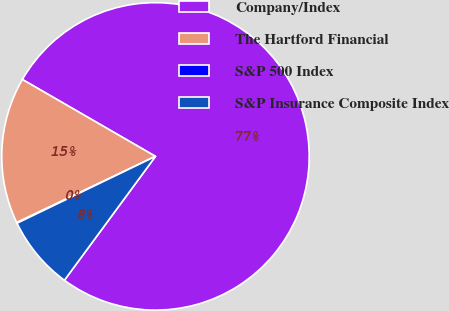Convert chart to OTSL. <chart><loc_0><loc_0><loc_500><loc_500><pie_chart><fcel>Company/Index<fcel>The Hartford Financial<fcel>S&P 500 Index<fcel>S&P Insurance Composite Index<nl><fcel>76.76%<fcel>15.42%<fcel>0.08%<fcel>7.75%<nl></chart> 